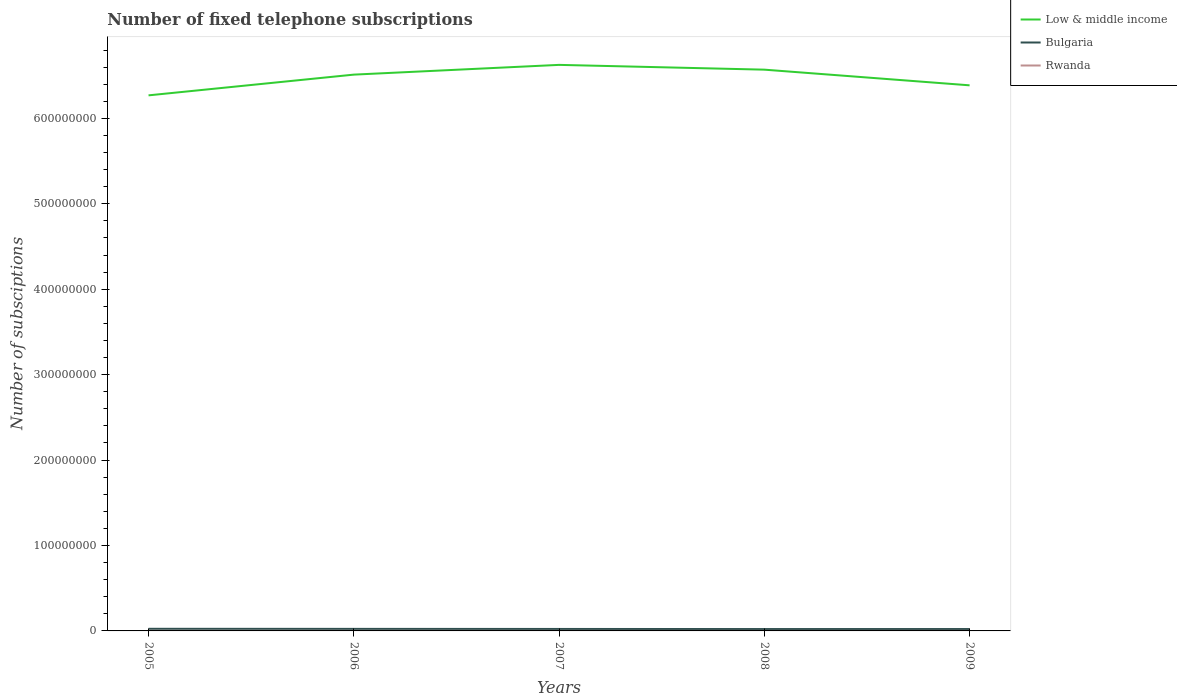Does the line corresponding to Low & middle income intersect with the line corresponding to Rwanda?
Offer a very short reply. No. Is the number of lines equal to the number of legend labels?
Offer a terse response. Yes. Across all years, what is the maximum number of fixed telephone subscriptions in Low & middle income?
Give a very brief answer. 6.27e+08. What is the total number of fixed telephone subscriptions in Rwanda in the graph?
Your answer should be very brief. -1.03e+04. What is the difference between the highest and the second highest number of fixed telephone subscriptions in Bulgaria?
Offer a terse response. 3.00e+05. Is the number of fixed telephone subscriptions in Low & middle income strictly greater than the number of fixed telephone subscriptions in Bulgaria over the years?
Your answer should be very brief. No. How many years are there in the graph?
Offer a terse response. 5. Are the values on the major ticks of Y-axis written in scientific E-notation?
Offer a terse response. No. Does the graph contain any zero values?
Your answer should be very brief. No. What is the title of the graph?
Your response must be concise. Number of fixed telephone subscriptions. Does "Sweden" appear as one of the legend labels in the graph?
Keep it short and to the point. No. What is the label or title of the X-axis?
Your answer should be compact. Years. What is the label or title of the Y-axis?
Ensure brevity in your answer.  Number of subsciptions. What is the Number of subsciptions in Low & middle income in 2005?
Offer a terse response. 6.27e+08. What is the Number of subsciptions of Bulgaria in 2005?
Ensure brevity in your answer.  2.49e+06. What is the Number of subsciptions of Rwanda in 2005?
Provide a succinct answer. 2.36e+04. What is the Number of subsciptions in Low & middle income in 2006?
Your response must be concise. 6.51e+08. What is the Number of subsciptions of Bulgaria in 2006?
Offer a very short reply. 2.40e+06. What is the Number of subsciptions in Rwanda in 2006?
Offer a very short reply. 2.34e+04. What is the Number of subsciptions in Low & middle income in 2007?
Provide a short and direct response. 6.63e+08. What is the Number of subsciptions of Bulgaria in 2007?
Offer a very short reply. 2.30e+06. What is the Number of subsciptions in Rwanda in 2007?
Make the answer very short. 2.31e+04. What is the Number of subsciptions in Low & middle income in 2008?
Ensure brevity in your answer.  6.57e+08. What is the Number of subsciptions of Bulgaria in 2008?
Make the answer very short. 2.19e+06. What is the Number of subsciptions in Rwanda in 2008?
Provide a succinct answer. 1.68e+04. What is the Number of subsciptions in Low & middle income in 2009?
Give a very brief answer. 6.39e+08. What is the Number of subsciptions of Bulgaria in 2009?
Ensure brevity in your answer.  2.21e+06. What is the Number of subsciptions in Rwanda in 2009?
Your answer should be very brief. 3.35e+04. Across all years, what is the maximum Number of subsciptions of Low & middle income?
Your answer should be compact. 6.63e+08. Across all years, what is the maximum Number of subsciptions of Bulgaria?
Give a very brief answer. 2.49e+06. Across all years, what is the maximum Number of subsciptions in Rwanda?
Offer a terse response. 3.35e+04. Across all years, what is the minimum Number of subsciptions of Low & middle income?
Your response must be concise. 6.27e+08. Across all years, what is the minimum Number of subsciptions in Bulgaria?
Give a very brief answer. 2.19e+06. Across all years, what is the minimum Number of subsciptions of Rwanda?
Your answer should be very brief. 1.68e+04. What is the total Number of subsciptions of Low & middle income in the graph?
Make the answer very short. 3.24e+09. What is the total Number of subsciptions in Bulgaria in the graph?
Your response must be concise. 1.16e+07. What is the total Number of subsciptions in Rwanda in the graph?
Offer a very short reply. 1.20e+05. What is the difference between the Number of subsciptions in Low & middle income in 2005 and that in 2006?
Ensure brevity in your answer.  -2.43e+07. What is the difference between the Number of subsciptions of Bulgaria in 2005 and that in 2006?
Give a very brief answer. 9.06e+04. What is the difference between the Number of subsciptions in Rwanda in 2005 and that in 2006?
Offer a very short reply. 239. What is the difference between the Number of subsciptions of Low & middle income in 2005 and that in 2007?
Your answer should be compact. -3.57e+07. What is the difference between the Number of subsciptions of Bulgaria in 2005 and that in 2007?
Offer a very short reply. 1.90e+05. What is the difference between the Number of subsciptions of Rwanda in 2005 and that in 2007?
Offer a terse response. 478. What is the difference between the Number of subsciptions in Low & middle income in 2005 and that in 2008?
Give a very brief answer. -3.01e+07. What is the difference between the Number of subsciptions of Bulgaria in 2005 and that in 2008?
Your answer should be compact. 3.00e+05. What is the difference between the Number of subsciptions in Rwanda in 2005 and that in 2008?
Provide a short and direct response. 6831. What is the difference between the Number of subsciptions of Low & middle income in 2005 and that in 2009?
Provide a short and direct response. -1.17e+07. What is the difference between the Number of subsciptions in Bulgaria in 2005 and that in 2009?
Ensure brevity in your answer.  2.85e+05. What is the difference between the Number of subsciptions of Rwanda in 2005 and that in 2009?
Your answer should be compact. -9850. What is the difference between the Number of subsciptions in Low & middle income in 2006 and that in 2007?
Ensure brevity in your answer.  -1.14e+07. What is the difference between the Number of subsciptions in Bulgaria in 2006 and that in 2007?
Offer a terse response. 9.91e+04. What is the difference between the Number of subsciptions in Rwanda in 2006 and that in 2007?
Your response must be concise. 239. What is the difference between the Number of subsciptions of Low & middle income in 2006 and that in 2008?
Your response must be concise. -5.82e+06. What is the difference between the Number of subsciptions of Bulgaria in 2006 and that in 2008?
Your answer should be compact. 2.10e+05. What is the difference between the Number of subsciptions of Rwanda in 2006 and that in 2008?
Provide a succinct answer. 6592. What is the difference between the Number of subsciptions in Low & middle income in 2006 and that in 2009?
Provide a short and direct response. 1.25e+07. What is the difference between the Number of subsciptions in Bulgaria in 2006 and that in 2009?
Your response must be concise. 1.94e+05. What is the difference between the Number of subsciptions in Rwanda in 2006 and that in 2009?
Your answer should be compact. -1.01e+04. What is the difference between the Number of subsciptions of Low & middle income in 2007 and that in 2008?
Provide a short and direct response. 5.59e+06. What is the difference between the Number of subsciptions in Bulgaria in 2007 and that in 2008?
Provide a succinct answer. 1.11e+05. What is the difference between the Number of subsciptions of Rwanda in 2007 and that in 2008?
Your response must be concise. 6353. What is the difference between the Number of subsciptions in Low & middle income in 2007 and that in 2009?
Offer a terse response. 2.39e+07. What is the difference between the Number of subsciptions in Bulgaria in 2007 and that in 2009?
Provide a succinct answer. 9.50e+04. What is the difference between the Number of subsciptions in Rwanda in 2007 and that in 2009?
Make the answer very short. -1.03e+04. What is the difference between the Number of subsciptions in Low & middle income in 2008 and that in 2009?
Your response must be concise. 1.83e+07. What is the difference between the Number of subsciptions of Bulgaria in 2008 and that in 2009?
Your answer should be compact. -1.56e+04. What is the difference between the Number of subsciptions of Rwanda in 2008 and that in 2009?
Give a very brief answer. -1.67e+04. What is the difference between the Number of subsciptions of Low & middle income in 2005 and the Number of subsciptions of Bulgaria in 2006?
Provide a short and direct response. 6.25e+08. What is the difference between the Number of subsciptions in Low & middle income in 2005 and the Number of subsciptions in Rwanda in 2006?
Provide a succinct answer. 6.27e+08. What is the difference between the Number of subsciptions of Bulgaria in 2005 and the Number of subsciptions of Rwanda in 2006?
Ensure brevity in your answer.  2.47e+06. What is the difference between the Number of subsciptions in Low & middle income in 2005 and the Number of subsciptions in Bulgaria in 2007?
Your answer should be very brief. 6.25e+08. What is the difference between the Number of subsciptions in Low & middle income in 2005 and the Number of subsciptions in Rwanda in 2007?
Give a very brief answer. 6.27e+08. What is the difference between the Number of subsciptions in Bulgaria in 2005 and the Number of subsciptions in Rwanda in 2007?
Give a very brief answer. 2.47e+06. What is the difference between the Number of subsciptions of Low & middle income in 2005 and the Number of subsciptions of Bulgaria in 2008?
Your response must be concise. 6.25e+08. What is the difference between the Number of subsciptions in Low & middle income in 2005 and the Number of subsciptions in Rwanda in 2008?
Your answer should be compact. 6.27e+08. What is the difference between the Number of subsciptions of Bulgaria in 2005 and the Number of subsciptions of Rwanda in 2008?
Ensure brevity in your answer.  2.47e+06. What is the difference between the Number of subsciptions in Low & middle income in 2005 and the Number of subsciptions in Bulgaria in 2009?
Your answer should be compact. 6.25e+08. What is the difference between the Number of subsciptions in Low & middle income in 2005 and the Number of subsciptions in Rwanda in 2009?
Keep it short and to the point. 6.27e+08. What is the difference between the Number of subsciptions in Bulgaria in 2005 and the Number of subsciptions in Rwanda in 2009?
Give a very brief answer. 2.46e+06. What is the difference between the Number of subsciptions of Low & middle income in 2006 and the Number of subsciptions of Bulgaria in 2007?
Ensure brevity in your answer.  6.49e+08. What is the difference between the Number of subsciptions of Low & middle income in 2006 and the Number of subsciptions of Rwanda in 2007?
Offer a terse response. 6.51e+08. What is the difference between the Number of subsciptions in Bulgaria in 2006 and the Number of subsciptions in Rwanda in 2007?
Your answer should be compact. 2.38e+06. What is the difference between the Number of subsciptions in Low & middle income in 2006 and the Number of subsciptions in Bulgaria in 2008?
Your answer should be compact. 6.49e+08. What is the difference between the Number of subsciptions in Low & middle income in 2006 and the Number of subsciptions in Rwanda in 2008?
Your answer should be compact. 6.51e+08. What is the difference between the Number of subsciptions in Bulgaria in 2006 and the Number of subsciptions in Rwanda in 2008?
Provide a succinct answer. 2.38e+06. What is the difference between the Number of subsciptions of Low & middle income in 2006 and the Number of subsciptions of Bulgaria in 2009?
Provide a short and direct response. 6.49e+08. What is the difference between the Number of subsciptions of Low & middle income in 2006 and the Number of subsciptions of Rwanda in 2009?
Your response must be concise. 6.51e+08. What is the difference between the Number of subsciptions of Bulgaria in 2006 and the Number of subsciptions of Rwanda in 2009?
Give a very brief answer. 2.37e+06. What is the difference between the Number of subsciptions of Low & middle income in 2007 and the Number of subsciptions of Bulgaria in 2008?
Provide a succinct answer. 6.60e+08. What is the difference between the Number of subsciptions of Low & middle income in 2007 and the Number of subsciptions of Rwanda in 2008?
Offer a very short reply. 6.63e+08. What is the difference between the Number of subsciptions of Bulgaria in 2007 and the Number of subsciptions of Rwanda in 2008?
Provide a succinct answer. 2.28e+06. What is the difference between the Number of subsciptions in Low & middle income in 2007 and the Number of subsciptions in Bulgaria in 2009?
Keep it short and to the point. 6.60e+08. What is the difference between the Number of subsciptions of Low & middle income in 2007 and the Number of subsciptions of Rwanda in 2009?
Provide a succinct answer. 6.63e+08. What is the difference between the Number of subsciptions of Bulgaria in 2007 and the Number of subsciptions of Rwanda in 2009?
Offer a very short reply. 2.27e+06. What is the difference between the Number of subsciptions of Low & middle income in 2008 and the Number of subsciptions of Bulgaria in 2009?
Keep it short and to the point. 6.55e+08. What is the difference between the Number of subsciptions in Low & middle income in 2008 and the Number of subsciptions in Rwanda in 2009?
Make the answer very short. 6.57e+08. What is the difference between the Number of subsciptions in Bulgaria in 2008 and the Number of subsciptions in Rwanda in 2009?
Your answer should be very brief. 2.16e+06. What is the average Number of subsciptions in Low & middle income per year?
Give a very brief answer. 6.47e+08. What is the average Number of subsciptions of Bulgaria per year?
Provide a short and direct response. 2.32e+06. What is the average Number of subsciptions in Rwanda per year?
Your answer should be very brief. 2.41e+04. In the year 2005, what is the difference between the Number of subsciptions in Low & middle income and Number of subsciptions in Bulgaria?
Give a very brief answer. 6.24e+08. In the year 2005, what is the difference between the Number of subsciptions of Low & middle income and Number of subsciptions of Rwanda?
Your answer should be very brief. 6.27e+08. In the year 2005, what is the difference between the Number of subsciptions in Bulgaria and Number of subsciptions in Rwanda?
Your answer should be very brief. 2.47e+06. In the year 2006, what is the difference between the Number of subsciptions in Low & middle income and Number of subsciptions in Bulgaria?
Your answer should be compact. 6.49e+08. In the year 2006, what is the difference between the Number of subsciptions in Low & middle income and Number of subsciptions in Rwanda?
Make the answer very short. 6.51e+08. In the year 2006, what is the difference between the Number of subsciptions of Bulgaria and Number of subsciptions of Rwanda?
Make the answer very short. 2.38e+06. In the year 2007, what is the difference between the Number of subsciptions in Low & middle income and Number of subsciptions in Bulgaria?
Your answer should be very brief. 6.60e+08. In the year 2007, what is the difference between the Number of subsciptions in Low & middle income and Number of subsciptions in Rwanda?
Offer a terse response. 6.63e+08. In the year 2007, what is the difference between the Number of subsciptions in Bulgaria and Number of subsciptions in Rwanda?
Provide a short and direct response. 2.28e+06. In the year 2008, what is the difference between the Number of subsciptions in Low & middle income and Number of subsciptions in Bulgaria?
Keep it short and to the point. 6.55e+08. In the year 2008, what is the difference between the Number of subsciptions of Low & middle income and Number of subsciptions of Rwanda?
Offer a very short reply. 6.57e+08. In the year 2008, what is the difference between the Number of subsciptions of Bulgaria and Number of subsciptions of Rwanda?
Provide a succinct answer. 2.17e+06. In the year 2009, what is the difference between the Number of subsciptions in Low & middle income and Number of subsciptions in Bulgaria?
Your answer should be compact. 6.37e+08. In the year 2009, what is the difference between the Number of subsciptions in Low & middle income and Number of subsciptions in Rwanda?
Your answer should be compact. 6.39e+08. In the year 2009, what is the difference between the Number of subsciptions of Bulgaria and Number of subsciptions of Rwanda?
Your answer should be compact. 2.17e+06. What is the ratio of the Number of subsciptions of Low & middle income in 2005 to that in 2006?
Keep it short and to the point. 0.96. What is the ratio of the Number of subsciptions of Bulgaria in 2005 to that in 2006?
Your response must be concise. 1.04. What is the ratio of the Number of subsciptions of Rwanda in 2005 to that in 2006?
Offer a very short reply. 1.01. What is the ratio of the Number of subsciptions of Low & middle income in 2005 to that in 2007?
Ensure brevity in your answer.  0.95. What is the ratio of the Number of subsciptions of Bulgaria in 2005 to that in 2007?
Provide a succinct answer. 1.08. What is the ratio of the Number of subsciptions of Rwanda in 2005 to that in 2007?
Your response must be concise. 1.02. What is the ratio of the Number of subsciptions in Low & middle income in 2005 to that in 2008?
Ensure brevity in your answer.  0.95. What is the ratio of the Number of subsciptions of Bulgaria in 2005 to that in 2008?
Provide a short and direct response. 1.14. What is the ratio of the Number of subsciptions of Rwanda in 2005 to that in 2008?
Make the answer very short. 1.41. What is the ratio of the Number of subsciptions in Low & middle income in 2005 to that in 2009?
Provide a short and direct response. 0.98. What is the ratio of the Number of subsciptions in Bulgaria in 2005 to that in 2009?
Make the answer very short. 1.13. What is the ratio of the Number of subsciptions in Rwanda in 2005 to that in 2009?
Ensure brevity in your answer.  0.71. What is the ratio of the Number of subsciptions in Low & middle income in 2006 to that in 2007?
Ensure brevity in your answer.  0.98. What is the ratio of the Number of subsciptions of Bulgaria in 2006 to that in 2007?
Your answer should be very brief. 1.04. What is the ratio of the Number of subsciptions in Rwanda in 2006 to that in 2007?
Offer a terse response. 1.01. What is the ratio of the Number of subsciptions of Low & middle income in 2006 to that in 2008?
Provide a succinct answer. 0.99. What is the ratio of the Number of subsciptions of Bulgaria in 2006 to that in 2008?
Make the answer very short. 1.1. What is the ratio of the Number of subsciptions in Rwanda in 2006 to that in 2008?
Your response must be concise. 1.39. What is the ratio of the Number of subsciptions of Low & middle income in 2006 to that in 2009?
Provide a short and direct response. 1.02. What is the ratio of the Number of subsciptions of Bulgaria in 2006 to that in 2009?
Offer a terse response. 1.09. What is the ratio of the Number of subsciptions in Rwanda in 2006 to that in 2009?
Give a very brief answer. 0.7. What is the ratio of the Number of subsciptions of Low & middle income in 2007 to that in 2008?
Offer a very short reply. 1.01. What is the ratio of the Number of subsciptions of Bulgaria in 2007 to that in 2008?
Offer a terse response. 1.05. What is the ratio of the Number of subsciptions of Rwanda in 2007 to that in 2008?
Ensure brevity in your answer.  1.38. What is the ratio of the Number of subsciptions of Low & middle income in 2007 to that in 2009?
Your answer should be compact. 1.04. What is the ratio of the Number of subsciptions of Bulgaria in 2007 to that in 2009?
Keep it short and to the point. 1.04. What is the ratio of the Number of subsciptions in Rwanda in 2007 to that in 2009?
Offer a very short reply. 0.69. What is the ratio of the Number of subsciptions of Low & middle income in 2008 to that in 2009?
Your answer should be very brief. 1.03. What is the ratio of the Number of subsciptions of Bulgaria in 2008 to that in 2009?
Your answer should be very brief. 0.99. What is the ratio of the Number of subsciptions in Rwanda in 2008 to that in 2009?
Keep it short and to the point. 0.5. What is the difference between the highest and the second highest Number of subsciptions in Low & middle income?
Keep it short and to the point. 5.59e+06. What is the difference between the highest and the second highest Number of subsciptions of Bulgaria?
Your response must be concise. 9.06e+04. What is the difference between the highest and the second highest Number of subsciptions in Rwanda?
Offer a very short reply. 9850. What is the difference between the highest and the lowest Number of subsciptions in Low & middle income?
Provide a short and direct response. 3.57e+07. What is the difference between the highest and the lowest Number of subsciptions in Bulgaria?
Your response must be concise. 3.00e+05. What is the difference between the highest and the lowest Number of subsciptions of Rwanda?
Make the answer very short. 1.67e+04. 